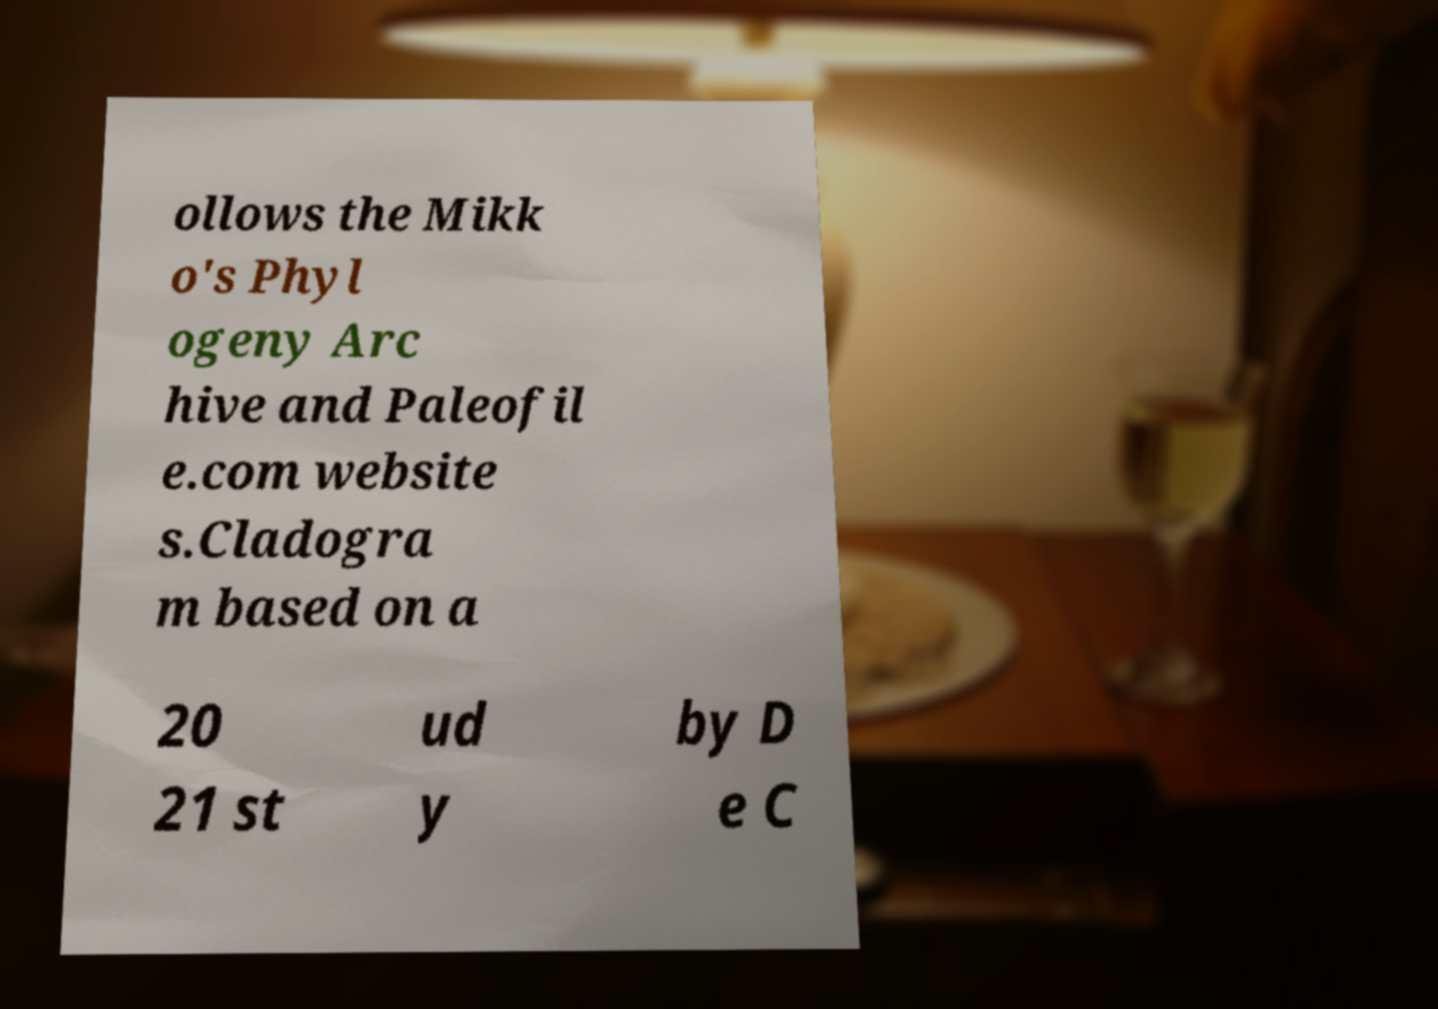Please read and relay the text visible in this image. What does it say? ollows the Mikk o's Phyl ogeny Arc hive and Paleofil e.com website s.Cladogra m based on a 20 21 st ud y by D e C 